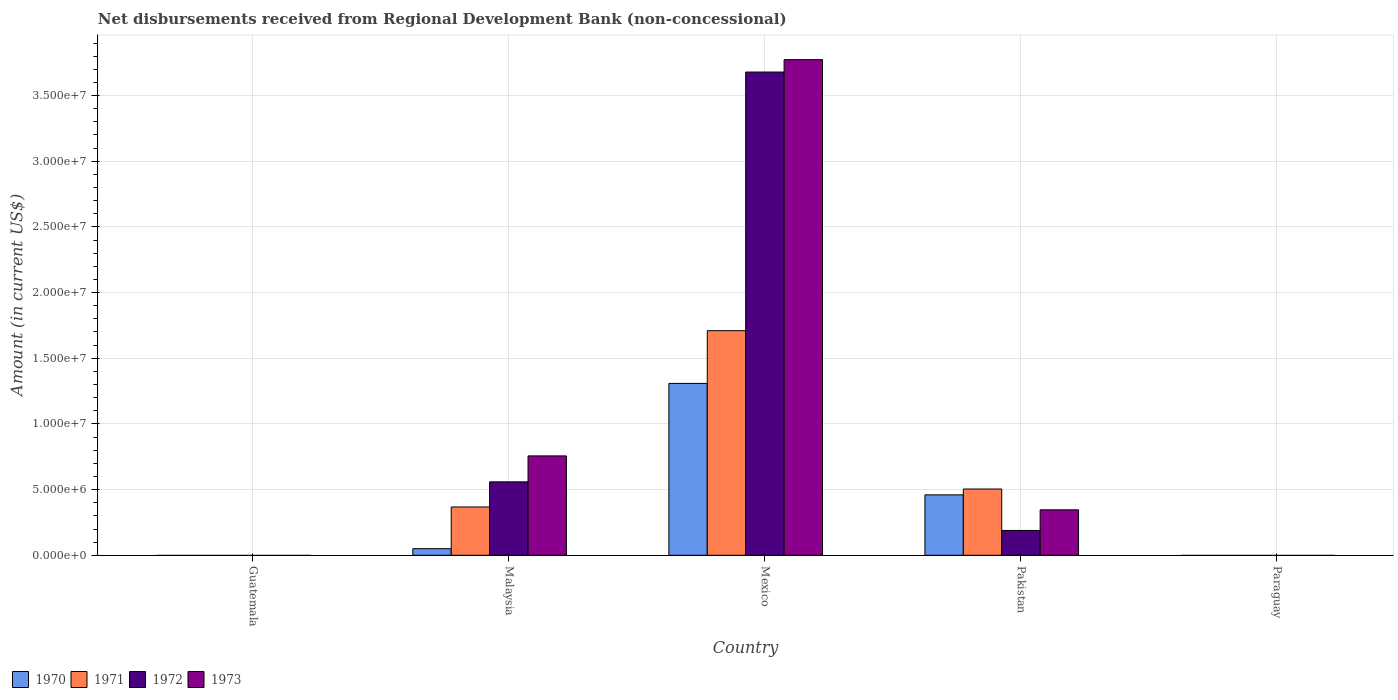How many different coloured bars are there?
Your answer should be very brief. 4. Are the number of bars per tick equal to the number of legend labels?
Your answer should be compact. No. Are the number of bars on each tick of the X-axis equal?
Provide a short and direct response. No. How many bars are there on the 1st tick from the right?
Provide a succinct answer. 0. What is the amount of disbursements received from Regional Development Bank in 1973 in Malaysia?
Offer a terse response. 7.57e+06. Across all countries, what is the maximum amount of disbursements received from Regional Development Bank in 1970?
Provide a short and direct response. 1.31e+07. Across all countries, what is the minimum amount of disbursements received from Regional Development Bank in 1973?
Offer a terse response. 0. What is the total amount of disbursements received from Regional Development Bank in 1973 in the graph?
Keep it short and to the point. 4.88e+07. What is the difference between the amount of disbursements received from Regional Development Bank in 1971 in Malaysia and that in Pakistan?
Ensure brevity in your answer.  -1.37e+06. What is the difference between the amount of disbursements received from Regional Development Bank in 1972 in Paraguay and the amount of disbursements received from Regional Development Bank in 1973 in Pakistan?
Ensure brevity in your answer.  -3.46e+06. What is the average amount of disbursements received from Regional Development Bank in 1973 per country?
Give a very brief answer. 9.75e+06. What is the difference between the amount of disbursements received from Regional Development Bank of/in 1971 and amount of disbursements received from Regional Development Bank of/in 1970 in Pakistan?
Your answer should be very brief. 4.45e+05. What is the ratio of the amount of disbursements received from Regional Development Bank in 1971 in Mexico to that in Pakistan?
Keep it short and to the point. 3.39. What is the difference between the highest and the second highest amount of disbursements received from Regional Development Bank in 1971?
Give a very brief answer. 1.21e+07. What is the difference between the highest and the lowest amount of disbursements received from Regional Development Bank in 1970?
Your answer should be compact. 1.31e+07. In how many countries, is the amount of disbursements received from Regional Development Bank in 1970 greater than the average amount of disbursements received from Regional Development Bank in 1970 taken over all countries?
Provide a succinct answer. 2. Is the sum of the amount of disbursements received from Regional Development Bank in 1972 in Malaysia and Pakistan greater than the maximum amount of disbursements received from Regional Development Bank in 1971 across all countries?
Your response must be concise. No. Is it the case that in every country, the sum of the amount of disbursements received from Regional Development Bank in 1972 and amount of disbursements received from Regional Development Bank in 1973 is greater than the sum of amount of disbursements received from Regional Development Bank in 1970 and amount of disbursements received from Regional Development Bank in 1971?
Make the answer very short. No. Are all the bars in the graph horizontal?
Offer a terse response. No. How many countries are there in the graph?
Ensure brevity in your answer.  5. What is the difference between two consecutive major ticks on the Y-axis?
Your response must be concise. 5.00e+06. Does the graph contain grids?
Make the answer very short. Yes. Where does the legend appear in the graph?
Ensure brevity in your answer.  Bottom left. How many legend labels are there?
Provide a succinct answer. 4. What is the title of the graph?
Give a very brief answer. Net disbursements received from Regional Development Bank (non-concessional). What is the label or title of the Y-axis?
Make the answer very short. Amount (in current US$). What is the Amount (in current US$) in 1970 in Malaysia?
Give a very brief answer. 5.02e+05. What is the Amount (in current US$) in 1971 in Malaysia?
Give a very brief answer. 3.68e+06. What is the Amount (in current US$) in 1972 in Malaysia?
Make the answer very short. 5.59e+06. What is the Amount (in current US$) of 1973 in Malaysia?
Ensure brevity in your answer.  7.57e+06. What is the Amount (in current US$) of 1970 in Mexico?
Your answer should be very brief. 1.31e+07. What is the Amount (in current US$) of 1971 in Mexico?
Offer a terse response. 1.71e+07. What is the Amount (in current US$) of 1972 in Mexico?
Your answer should be compact. 3.68e+07. What is the Amount (in current US$) of 1973 in Mexico?
Offer a very short reply. 3.77e+07. What is the Amount (in current US$) in 1970 in Pakistan?
Offer a very short reply. 4.60e+06. What is the Amount (in current US$) in 1971 in Pakistan?
Your answer should be compact. 5.04e+06. What is the Amount (in current US$) of 1972 in Pakistan?
Your answer should be very brief. 1.89e+06. What is the Amount (in current US$) in 1973 in Pakistan?
Ensure brevity in your answer.  3.46e+06. What is the Amount (in current US$) in 1970 in Paraguay?
Your answer should be very brief. 0. What is the Amount (in current US$) in 1971 in Paraguay?
Provide a succinct answer. 0. What is the Amount (in current US$) in 1972 in Paraguay?
Your answer should be very brief. 0. Across all countries, what is the maximum Amount (in current US$) of 1970?
Ensure brevity in your answer.  1.31e+07. Across all countries, what is the maximum Amount (in current US$) in 1971?
Your answer should be compact. 1.71e+07. Across all countries, what is the maximum Amount (in current US$) of 1972?
Ensure brevity in your answer.  3.68e+07. Across all countries, what is the maximum Amount (in current US$) of 1973?
Offer a very short reply. 3.77e+07. Across all countries, what is the minimum Amount (in current US$) of 1970?
Your response must be concise. 0. Across all countries, what is the minimum Amount (in current US$) in 1971?
Provide a succinct answer. 0. What is the total Amount (in current US$) of 1970 in the graph?
Provide a short and direct response. 1.82e+07. What is the total Amount (in current US$) in 1971 in the graph?
Ensure brevity in your answer.  2.58e+07. What is the total Amount (in current US$) of 1972 in the graph?
Provide a short and direct response. 4.43e+07. What is the total Amount (in current US$) in 1973 in the graph?
Give a very brief answer. 4.88e+07. What is the difference between the Amount (in current US$) of 1970 in Malaysia and that in Mexico?
Give a very brief answer. -1.26e+07. What is the difference between the Amount (in current US$) of 1971 in Malaysia and that in Mexico?
Ensure brevity in your answer.  -1.34e+07. What is the difference between the Amount (in current US$) of 1972 in Malaysia and that in Mexico?
Provide a short and direct response. -3.12e+07. What is the difference between the Amount (in current US$) in 1973 in Malaysia and that in Mexico?
Offer a terse response. -3.02e+07. What is the difference between the Amount (in current US$) in 1970 in Malaysia and that in Pakistan?
Make the answer very short. -4.10e+06. What is the difference between the Amount (in current US$) of 1971 in Malaysia and that in Pakistan?
Offer a terse response. -1.37e+06. What is the difference between the Amount (in current US$) of 1972 in Malaysia and that in Pakistan?
Keep it short and to the point. 3.70e+06. What is the difference between the Amount (in current US$) of 1973 in Malaysia and that in Pakistan?
Your answer should be very brief. 4.10e+06. What is the difference between the Amount (in current US$) in 1970 in Mexico and that in Pakistan?
Keep it short and to the point. 8.48e+06. What is the difference between the Amount (in current US$) of 1971 in Mexico and that in Pakistan?
Your answer should be very brief. 1.21e+07. What is the difference between the Amount (in current US$) in 1972 in Mexico and that in Pakistan?
Ensure brevity in your answer.  3.49e+07. What is the difference between the Amount (in current US$) in 1973 in Mexico and that in Pakistan?
Provide a short and direct response. 3.43e+07. What is the difference between the Amount (in current US$) of 1970 in Malaysia and the Amount (in current US$) of 1971 in Mexico?
Keep it short and to the point. -1.66e+07. What is the difference between the Amount (in current US$) in 1970 in Malaysia and the Amount (in current US$) in 1972 in Mexico?
Give a very brief answer. -3.63e+07. What is the difference between the Amount (in current US$) of 1970 in Malaysia and the Amount (in current US$) of 1973 in Mexico?
Offer a terse response. -3.72e+07. What is the difference between the Amount (in current US$) in 1971 in Malaysia and the Amount (in current US$) in 1972 in Mexico?
Offer a terse response. -3.31e+07. What is the difference between the Amount (in current US$) of 1971 in Malaysia and the Amount (in current US$) of 1973 in Mexico?
Ensure brevity in your answer.  -3.41e+07. What is the difference between the Amount (in current US$) in 1972 in Malaysia and the Amount (in current US$) in 1973 in Mexico?
Offer a very short reply. -3.21e+07. What is the difference between the Amount (in current US$) in 1970 in Malaysia and the Amount (in current US$) in 1971 in Pakistan?
Provide a short and direct response. -4.54e+06. What is the difference between the Amount (in current US$) in 1970 in Malaysia and the Amount (in current US$) in 1972 in Pakistan?
Keep it short and to the point. -1.39e+06. What is the difference between the Amount (in current US$) of 1970 in Malaysia and the Amount (in current US$) of 1973 in Pakistan?
Offer a terse response. -2.96e+06. What is the difference between the Amount (in current US$) of 1971 in Malaysia and the Amount (in current US$) of 1972 in Pakistan?
Your response must be concise. 1.79e+06. What is the difference between the Amount (in current US$) of 1971 in Malaysia and the Amount (in current US$) of 1973 in Pakistan?
Offer a terse response. 2.16e+05. What is the difference between the Amount (in current US$) of 1972 in Malaysia and the Amount (in current US$) of 1973 in Pakistan?
Offer a very short reply. 2.13e+06. What is the difference between the Amount (in current US$) in 1970 in Mexico and the Amount (in current US$) in 1971 in Pakistan?
Keep it short and to the point. 8.04e+06. What is the difference between the Amount (in current US$) in 1970 in Mexico and the Amount (in current US$) in 1972 in Pakistan?
Provide a succinct answer. 1.12e+07. What is the difference between the Amount (in current US$) of 1970 in Mexico and the Amount (in current US$) of 1973 in Pakistan?
Give a very brief answer. 9.62e+06. What is the difference between the Amount (in current US$) in 1971 in Mexico and the Amount (in current US$) in 1972 in Pakistan?
Your response must be concise. 1.52e+07. What is the difference between the Amount (in current US$) of 1971 in Mexico and the Amount (in current US$) of 1973 in Pakistan?
Your response must be concise. 1.36e+07. What is the difference between the Amount (in current US$) in 1972 in Mexico and the Amount (in current US$) in 1973 in Pakistan?
Your answer should be compact. 3.33e+07. What is the average Amount (in current US$) in 1970 per country?
Keep it short and to the point. 3.64e+06. What is the average Amount (in current US$) of 1971 per country?
Provide a succinct answer. 5.16e+06. What is the average Amount (in current US$) of 1972 per country?
Keep it short and to the point. 8.85e+06. What is the average Amount (in current US$) of 1973 per country?
Your response must be concise. 9.75e+06. What is the difference between the Amount (in current US$) of 1970 and Amount (in current US$) of 1971 in Malaysia?
Your answer should be very brief. -3.18e+06. What is the difference between the Amount (in current US$) of 1970 and Amount (in current US$) of 1972 in Malaysia?
Give a very brief answer. -5.09e+06. What is the difference between the Amount (in current US$) in 1970 and Amount (in current US$) in 1973 in Malaysia?
Offer a terse response. -7.06e+06. What is the difference between the Amount (in current US$) of 1971 and Amount (in current US$) of 1972 in Malaysia?
Ensure brevity in your answer.  -1.91e+06. What is the difference between the Amount (in current US$) in 1971 and Amount (in current US$) in 1973 in Malaysia?
Give a very brief answer. -3.89e+06. What is the difference between the Amount (in current US$) of 1972 and Amount (in current US$) of 1973 in Malaysia?
Ensure brevity in your answer.  -1.98e+06. What is the difference between the Amount (in current US$) of 1970 and Amount (in current US$) of 1971 in Mexico?
Provide a short and direct response. -4.02e+06. What is the difference between the Amount (in current US$) in 1970 and Amount (in current US$) in 1972 in Mexico?
Offer a very short reply. -2.37e+07. What is the difference between the Amount (in current US$) of 1970 and Amount (in current US$) of 1973 in Mexico?
Offer a very short reply. -2.46e+07. What is the difference between the Amount (in current US$) of 1971 and Amount (in current US$) of 1972 in Mexico?
Give a very brief answer. -1.97e+07. What is the difference between the Amount (in current US$) in 1971 and Amount (in current US$) in 1973 in Mexico?
Ensure brevity in your answer.  -2.06e+07. What is the difference between the Amount (in current US$) of 1972 and Amount (in current US$) of 1973 in Mexico?
Your answer should be compact. -9.43e+05. What is the difference between the Amount (in current US$) in 1970 and Amount (in current US$) in 1971 in Pakistan?
Provide a succinct answer. -4.45e+05. What is the difference between the Amount (in current US$) of 1970 and Amount (in current US$) of 1972 in Pakistan?
Provide a succinct answer. 2.71e+06. What is the difference between the Amount (in current US$) in 1970 and Amount (in current US$) in 1973 in Pakistan?
Your response must be concise. 1.14e+06. What is the difference between the Amount (in current US$) of 1971 and Amount (in current US$) of 1972 in Pakistan?
Keep it short and to the point. 3.16e+06. What is the difference between the Amount (in current US$) in 1971 and Amount (in current US$) in 1973 in Pakistan?
Provide a succinct answer. 1.58e+06. What is the difference between the Amount (in current US$) in 1972 and Amount (in current US$) in 1973 in Pakistan?
Your response must be concise. -1.57e+06. What is the ratio of the Amount (in current US$) in 1970 in Malaysia to that in Mexico?
Make the answer very short. 0.04. What is the ratio of the Amount (in current US$) in 1971 in Malaysia to that in Mexico?
Provide a succinct answer. 0.21. What is the ratio of the Amount (in current US$) in 1972 in Malaysia to that in Mexico?
Keep it short and to the point. 0.15. What is the ratio of the Amount (in current US$) of 1973 in Malaysia to that in Mexico?
Make the answer very short. 0.2. What is the ratio of the Amount (in current US$) in 1970 in Malaysia to that in Pakistan?
Make the answer very short. 0.11. What is the ratio of the Amount (in current US$) in 1971 in Malaysia to that in Pakistan?
Make the answer very short. 0.73. What is the ratio of the Amount (in current US$) of 1972 in Malaysia to that in Pakistan?
Keep it short and to the point. 2.96. What is the ratio of the Amount (in current US$) of 1973 in Malaysia to that in Pakistan?
Keep it short and to the point. 2.19. What is the ratio of the Amount (in current US$) of 1970 in Mexico to that in Pakistan?
Your response must be concise. 2.84. What is the ratio of the Amount (in current US$) of 1971 in Mexico to that in Pakistan?
Offer a very short reply. 3.39. What is the ratio of the Amount (in current US$) of 1972 in Mexico to that in Pakistan?
Offer a terse response. 19.47. What is the ratio of the Amount (in current US$) in 1973 in Mexico to that in Pakistan?
Give a very brief answer. 10.9. What is the difference between the highest and the second highest Amount (in current US$) of 1970?
Your answer should be compact. 8.48e+06. What is the difference between the highest and the second highest Amount (in current US$) of 1971?
Ensure brevity in your answer.  1.21e+07. What is the difference between the highest and the second highest Amount (in current US$) in 1972?
Ensure brevity in your answer.  3.12e+07. What is the difference between the highest and the second highest Amount (in current US$) of 1973?
Offer a very short reply. 3.02e+07. What is the difference between the highest and the lowest Amount (in current US$) of 1970?
Offer a terse response. 1.31e+07. What is the difference between the highest and the lowest Amount (in current US$) in 1971?
Your answer should be compact. 1.71e+07. What is the difference between the highest and the lowest Amount (in current US$) of 1972?
Ensure brevity in your answer.  3.68e+07. What is the difference between the highest and the lowest Amount (in current US$) in 1973?
Provide a succinct answer. 3.77e+07. 